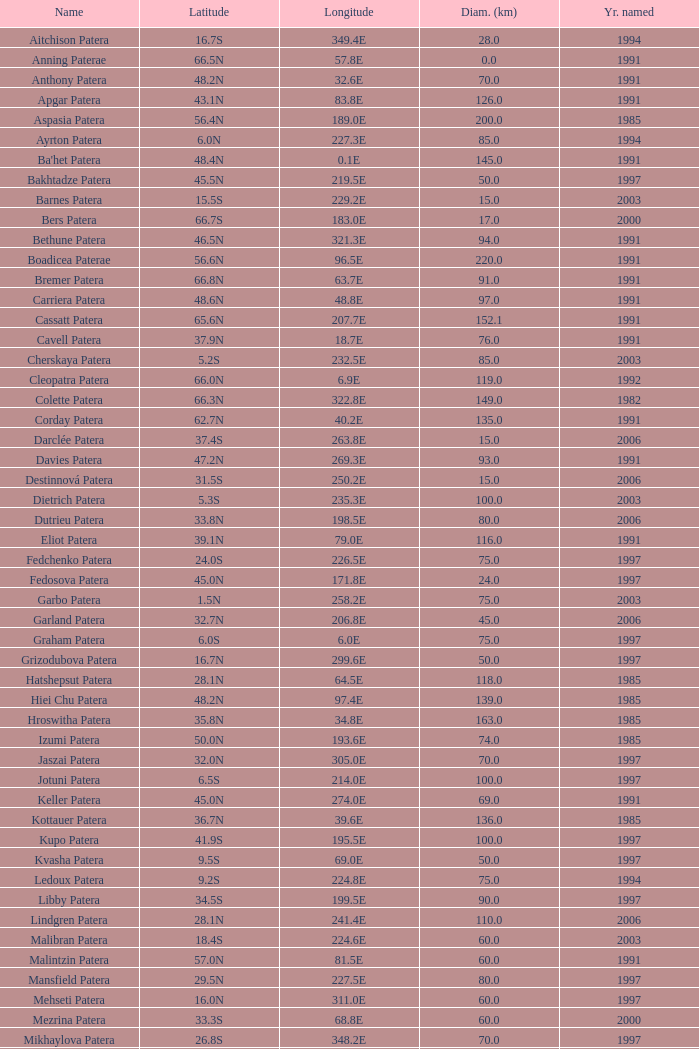What is Year Named, when Longitude is 227.5E? 1997.0. 